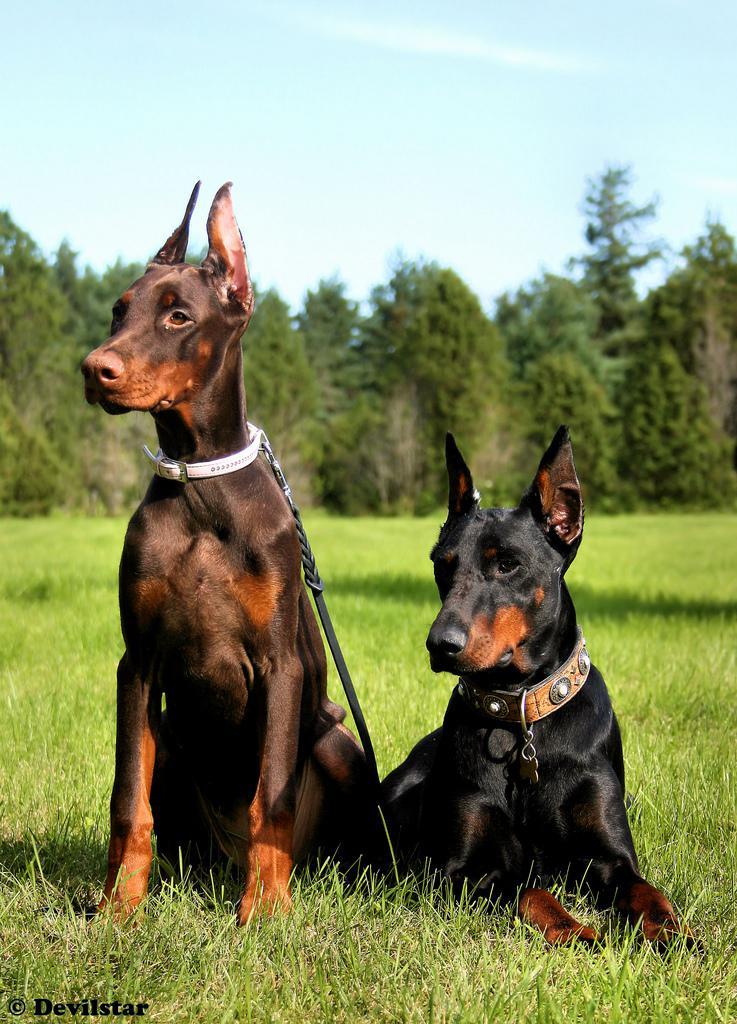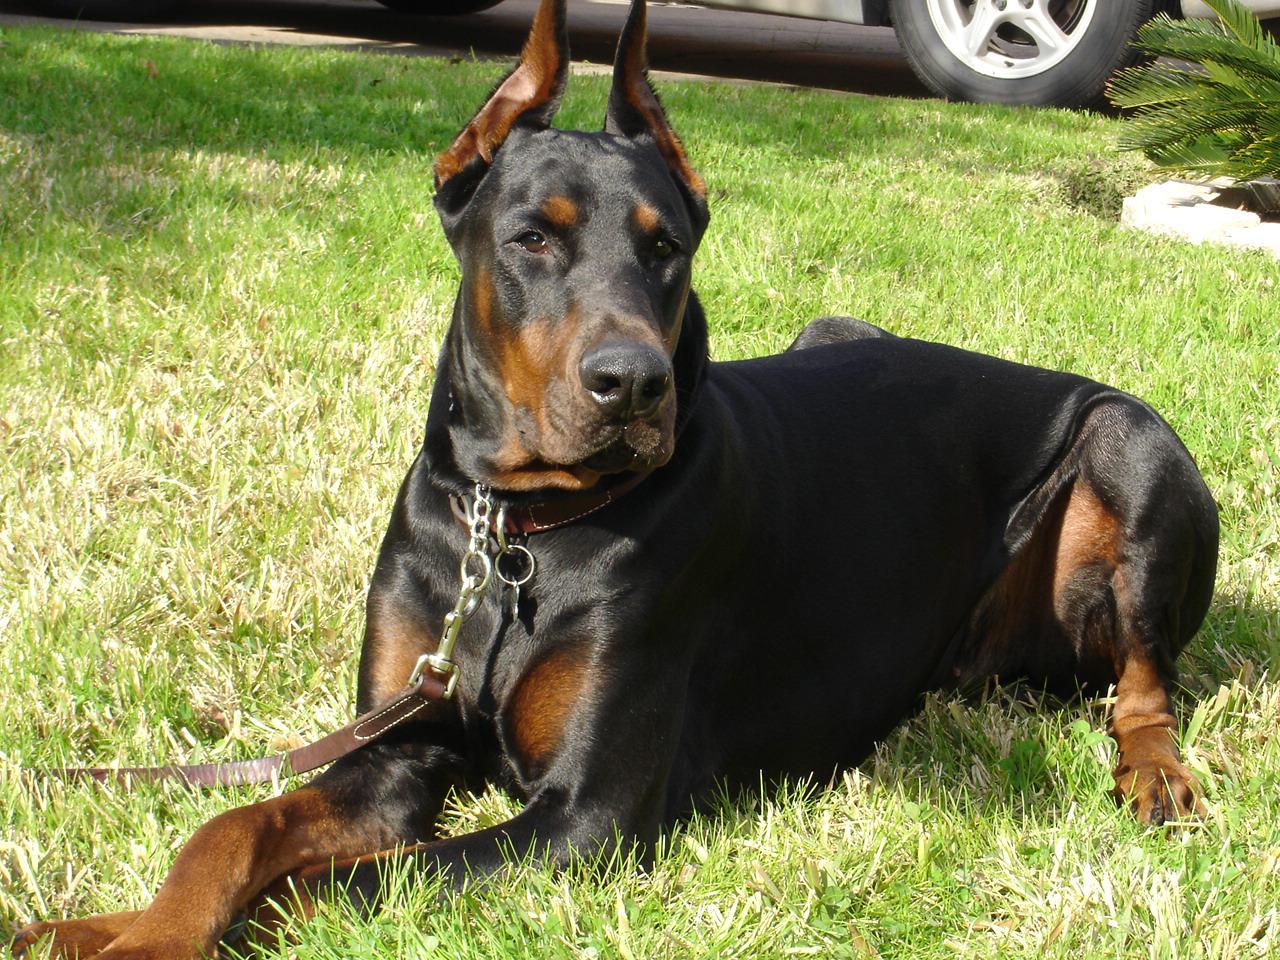The first image is the image on the left, the second image is the image on the right. For the images shown, is this caption "Every image shows exactly two dogs wearing collars, and no dog is actively hooked up to a leash." true? Answer yes or no. No. The first image is the image on the left, the second image is the image on the right. Analyze the images presented: Is the assertion "Two dogs are sitting in the grass in the image on the left, while two lie in the grass in the image on the right." valid? Answer yes or no. No. 